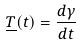<formula> <loc_0><loc_0><loc_500><loc_500>\underline { T } ( t ) = \frac { d \gamma } { d t }</formula> 